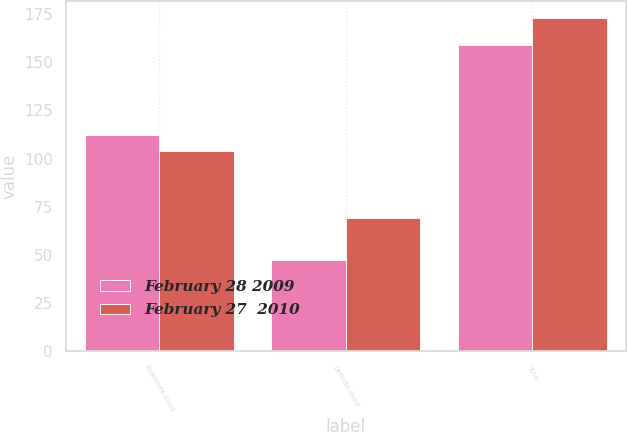Convert chart. <chart><loc_0><loc_0><loc_500><loc_500><stacked_bar_chart><ecel><fcel>Indefinite-lived<fcel>Definite-lived<fcel>Total<nl><fcel>February 28 2009<fcel>112<fcel>47<fcel>159<nl><fcel>February 27  2010<fcel>104<fcel>69<fcel>173<nl></chart> 